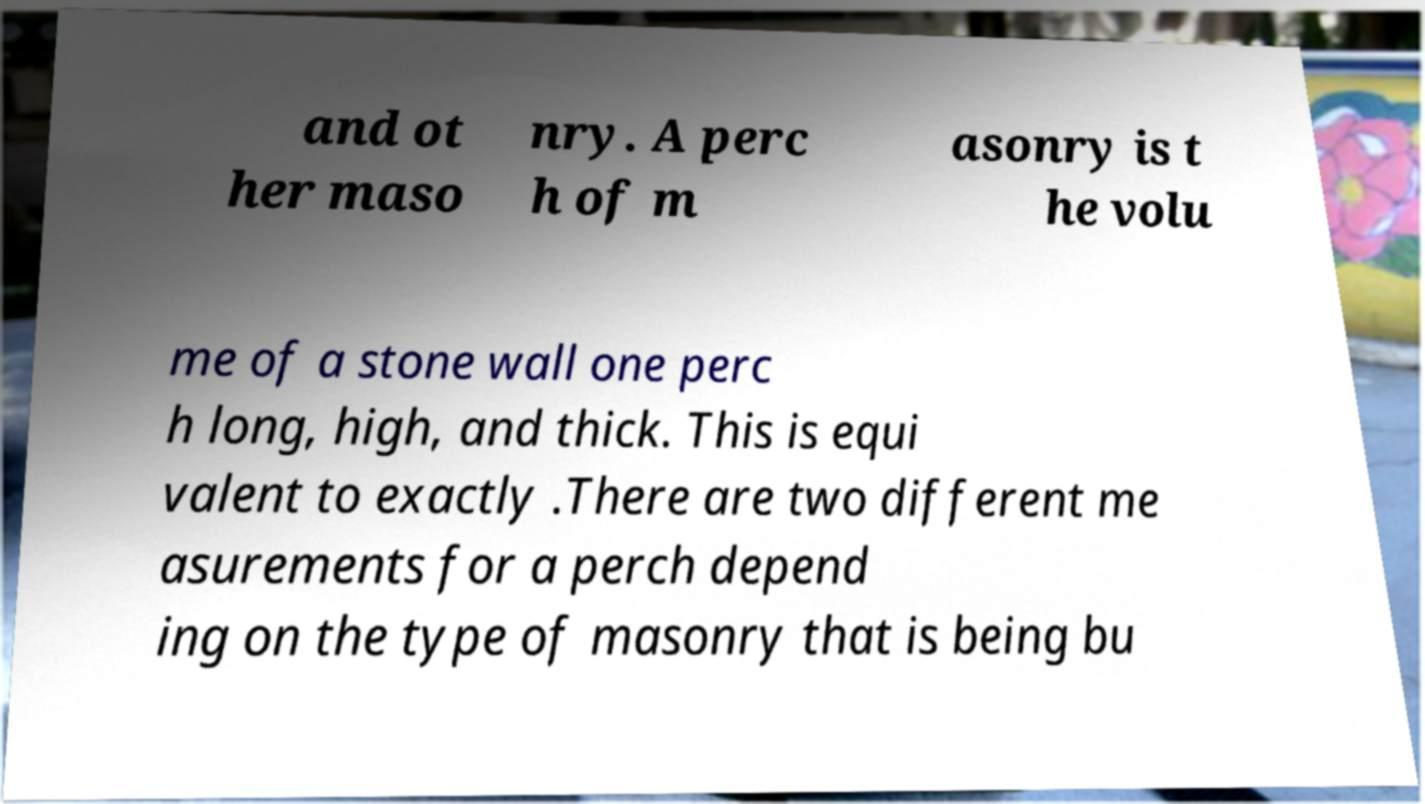Can you accurately transcribe the text from the provided image for me? and ot her maso nry. A perc h of m asonry is t he volu me of a stone wall one perc h long, high, and thick. This is equi valent to exactly .There are two different me asurements for a perch depend ing on the type of masonry that is being bu 